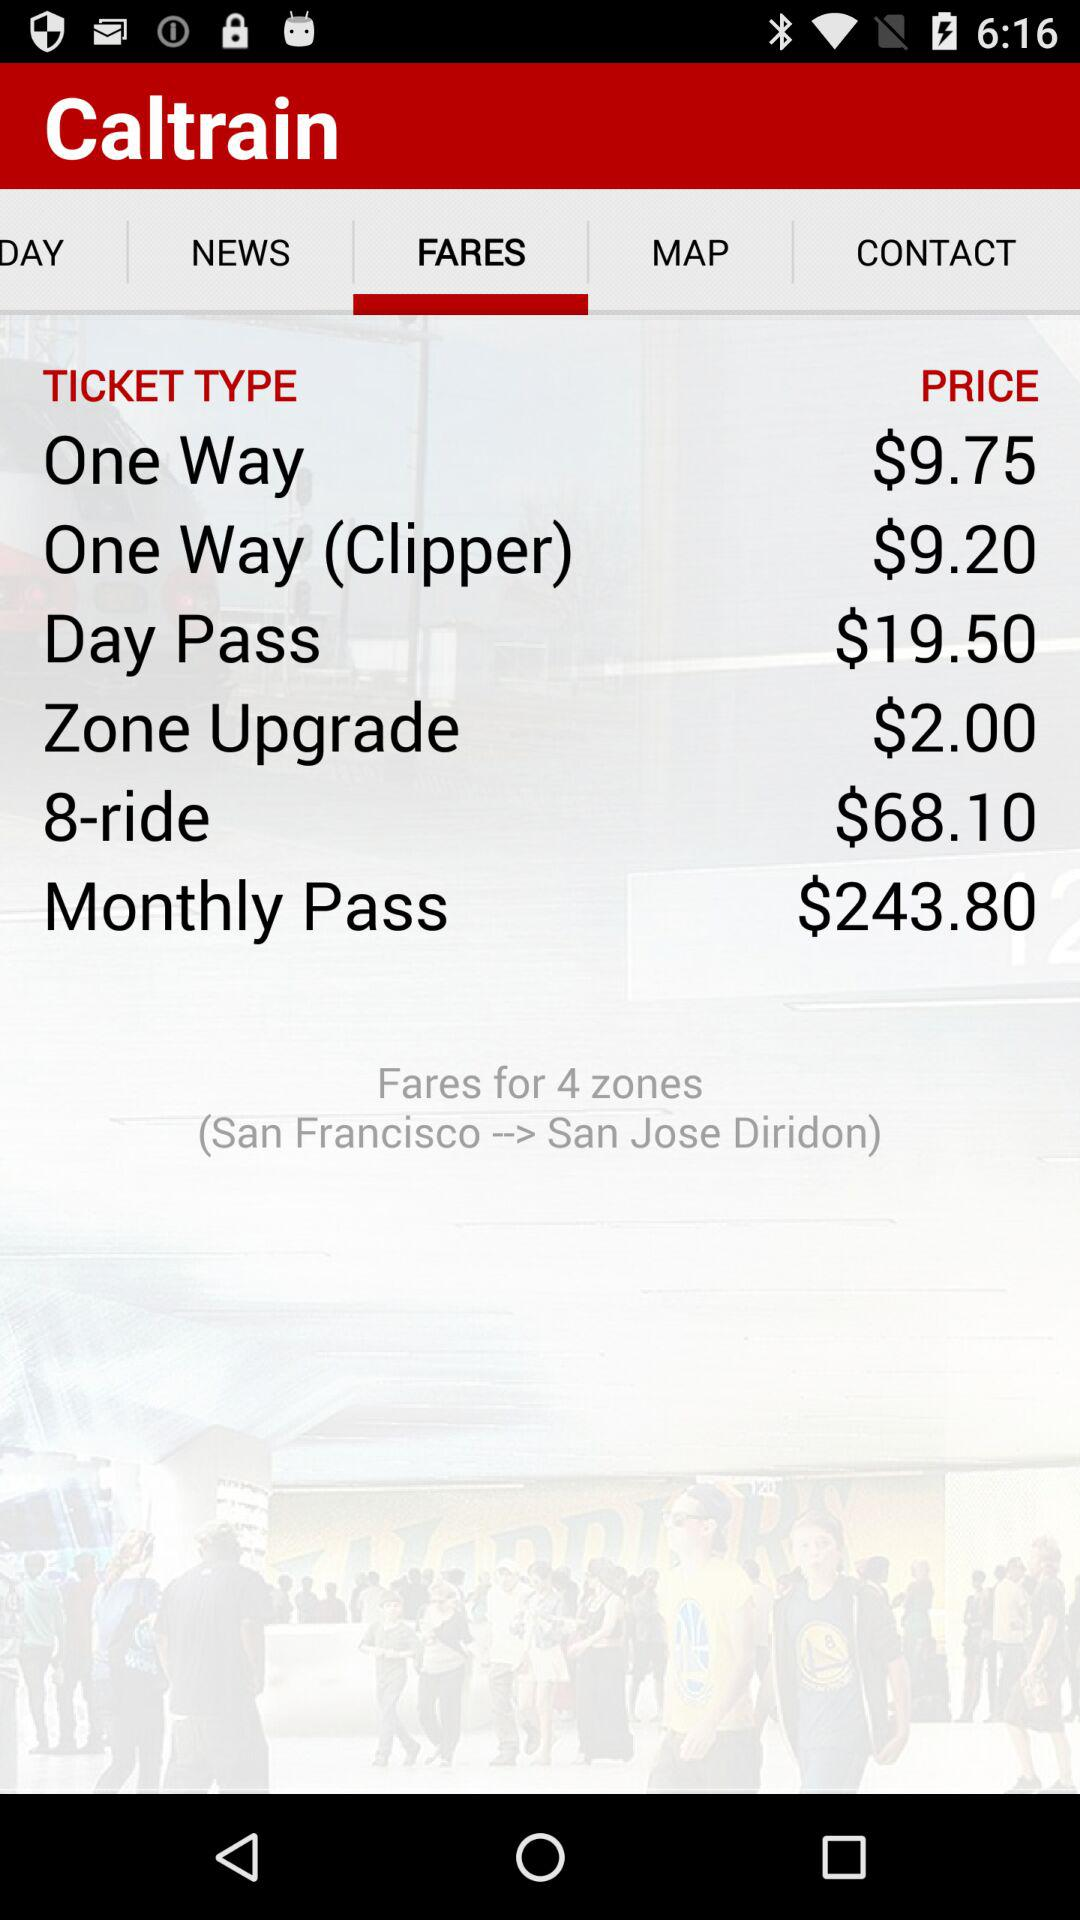What types of tickets are there? The types of tickets are "One Way", "One Way (Clipper)", "Day Pass", "Zone Upgrade", "8-ride" and "Monthly Pass". 